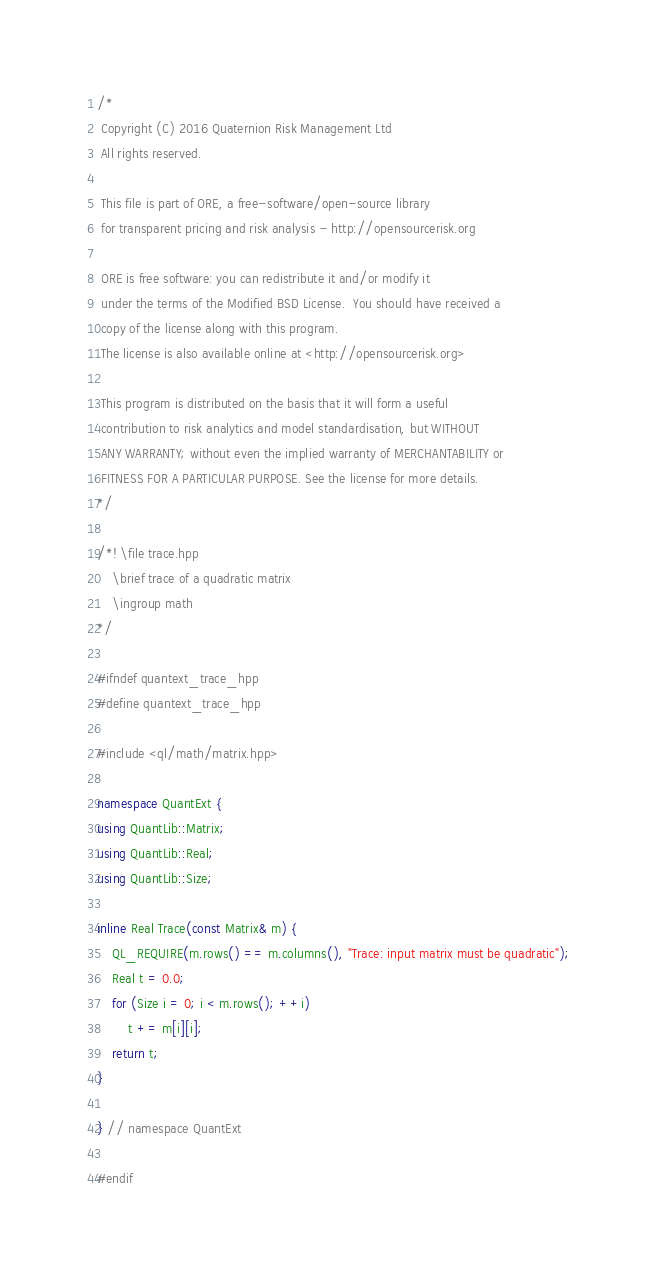<code> <loc_0><loc_0><loc_500><loc_500><_C++_>/*
 Copyright (C) 2016 Quaternion Risk Management Ltd
 All rights reserved.

 This file is part of ORE, a free-software/open-source library
 for transparent pricing and risk analysis - http://opensourcerisk.org

 ORE is free software: you can redistribute it and/or modify it
 under the terms of the Modified BSD License.  You should have received a
 copy of the license along with this program.
 The license is also available online at <http://opensourcerisk.org>

 This program is distributed on the basis that it will form a useful
 contribution to risk analytics and model standardisation, but WITHOUT
 ANY WARRANTY; without even the implied warranty of MERCHANTABILITY or
 FITNESS FOR A PARTICULAR PURPOSE. See the license for more details.
*/

/*! \file trace.hpp
    \brief trace of a quadratic matrix
    \ingroup math
*/

#ifndef quantext_trace_hpp
#define quantext_trace_hpp

#include <ql/math/matrix.hpp>

namespace QuantExt {
using QuantLib::Matrix;
using QuantLib::Real;
using QuantLib::Size;

inline Real Trace(const Matrix& m) {
    QL_REQUIRE(m.rows() == m.columns(), "Trace: input matrix must be quadratic");
    Real t = 0.0;
    for (Size i = 0; i < m.rows(); ++i)
        t += m[i][i];
    return t;
}

} // namespace QuantExt

#endif
</code> 